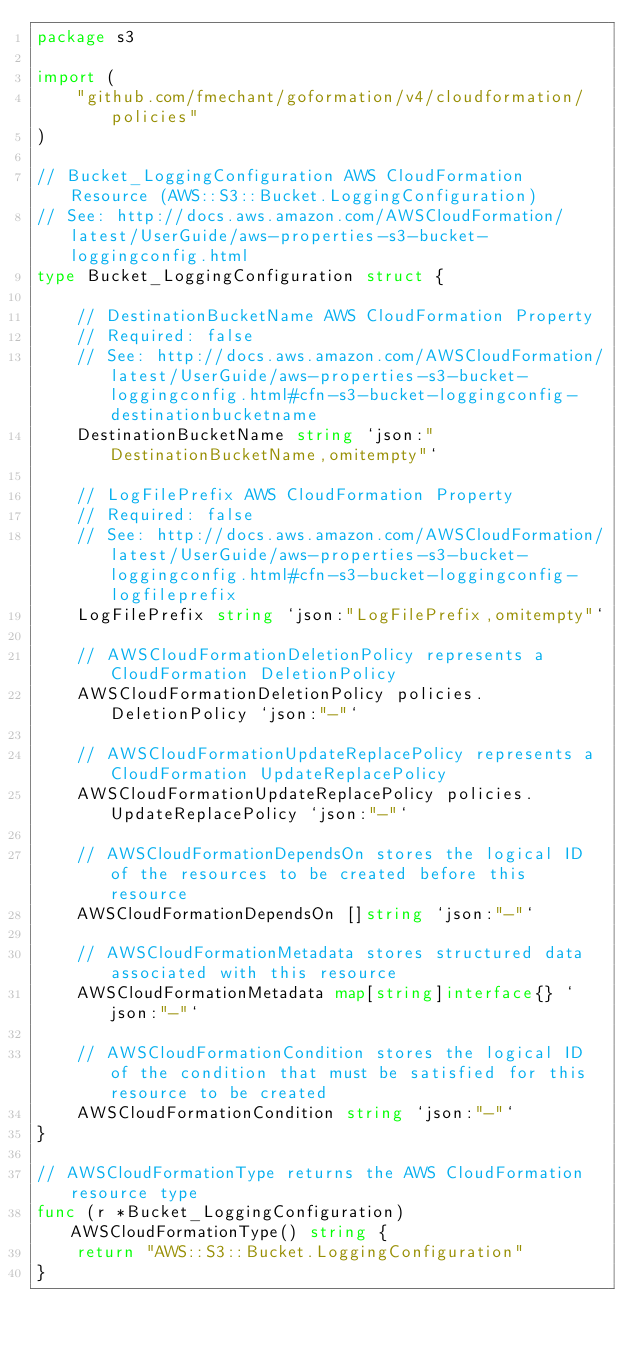<code> <loc_0><loc_0><loc_500><loc_500><_Go_>package s3

import (
	"github.com/fmechant/goformation/v4/cloudformation/policies"
)

// Bucket_LoggingConfiguration AWS CloudFormation Resource (AWS::S3::Bucket.LoggingConfiguration)
// See: http://docs.aws.amazon.com/AWSCloudFormation/latest/UserGuide/aws-properties-s3-bucket-loggingconfig.html
type Bucket_LoggingConfiguration struct {

	// DestinationBucketName AWS CloudFormation Property
	// Required: false
	// See: http://docs.aws.amazon.com/AWSCloudFormation/latest/UserGuide/aws-properties-s3-bucket-loggingconfig.html#cfn-s3-bucket-loggingconfig-destinationbucketname
	DestinationBucketName string `json:"DestinationBucketName,omitempty"`

	// LogFilePrefix AWS CloudFormation Property
	// Required: false
	// See: http://docs.aws.amazon.com/AWSCloudFormation/latest/UserGuide/aws-properties-s3-bucket-loggingconfig.html#cfn-s3-bucket-loggingconfig-logfileprefix
	LogFilePrefix string `json:"LogFilePrefix,omitempty"`

	// AWSCloudFormationDeletionPolicy represents a CloudFormation DeletionPolicy
	AWSCloudFormationDeletionPolicy policies.DeletionPolicy `json:"-"`

	// AWSCloudFormationUpdateReplacePolicy represents a CloudFormation UpdateReplacePolicy
	AWSCloudFormationUpdateReplacePolicy policies.UpdateReplacePolicy `json:"-"`

	// AWSCloudFormationDependsOn stores the logical ID of the resources to be created before this resource
	AWSCloudFormationDependsOn []string `json:"-"`

	// AWSCloudFormationMetadata stores structured data associated with this resource
	AWSCloudFormationMetadata map[string]interface{} `json:"-"`

	// AWSCloudFormationCondition stores the logical ID of the condition that must be satisfied for this resource to be created
	AWSCloudFormationCondition string `json:"-"`
}

// AWSCloudFormationType returns the AWS CloudFormation resource type
func (r *Bucket_LoggingConfiguration) AWSCloudFormationType() string {
	return "AWS::S3::Bucket.LoggingConfiguration"
}
</code> 